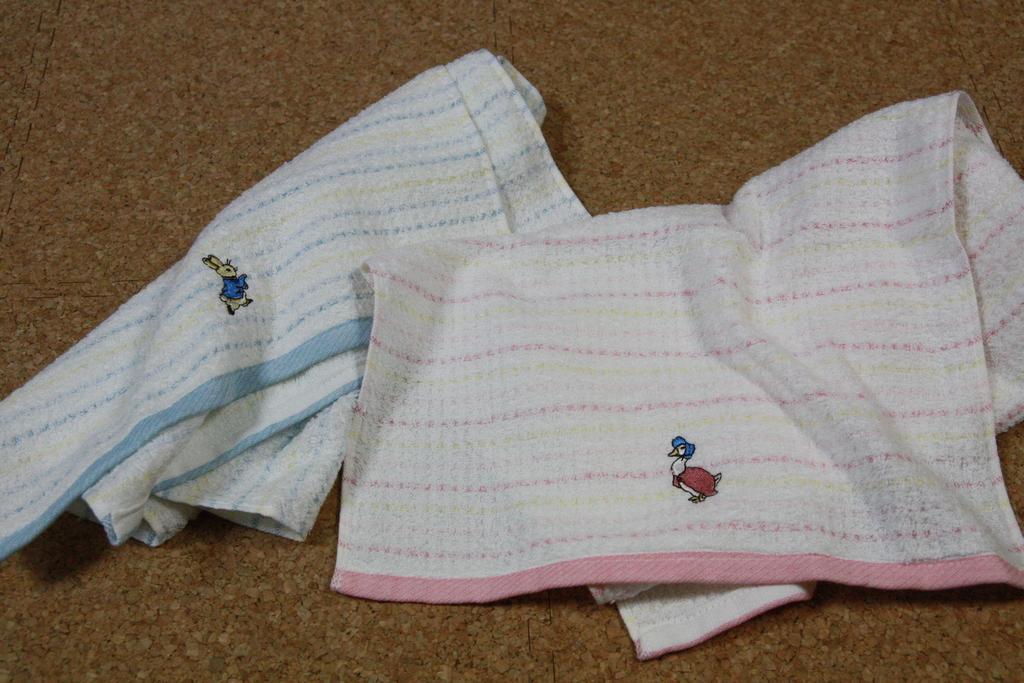How would you summarize this image in a sentence or two? In this image, we can see white clothes are placed on the surface. Here we can see some embroidery work. 